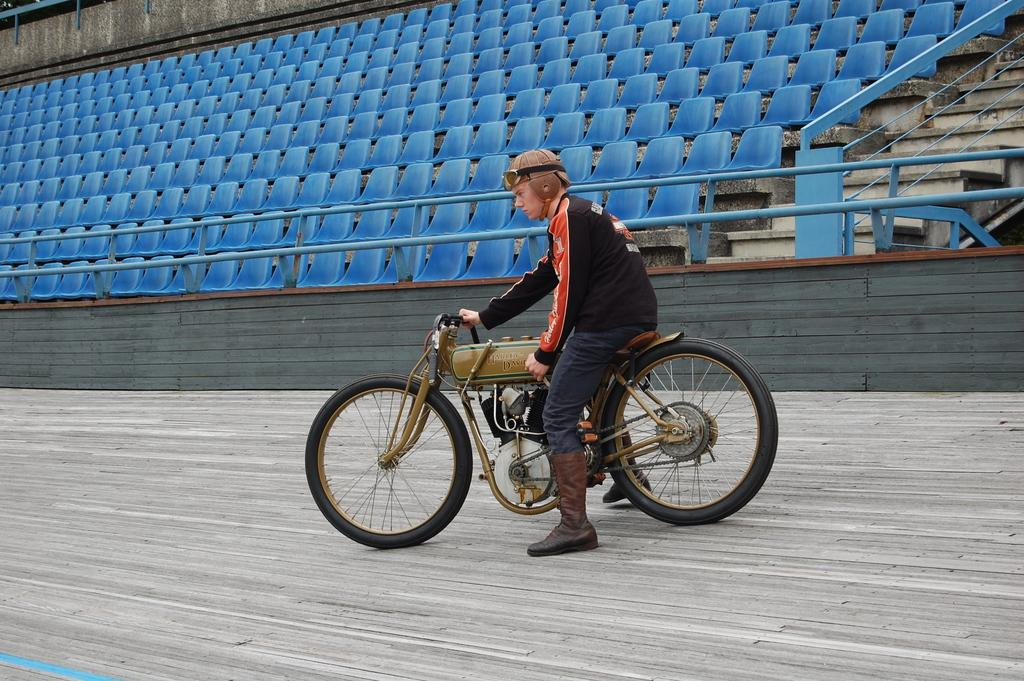Who is present in the image? There is a man in the image. What is the man doing in the image? The man is sitting on a motorcycle. What can be seen in the background of the image? There appears to be a gallery beside the man and motorcycle. What type of heart-shaped object can be seen on the motorcycle in the image? There is no heart-shaped object present on the motorcycle in the image. 